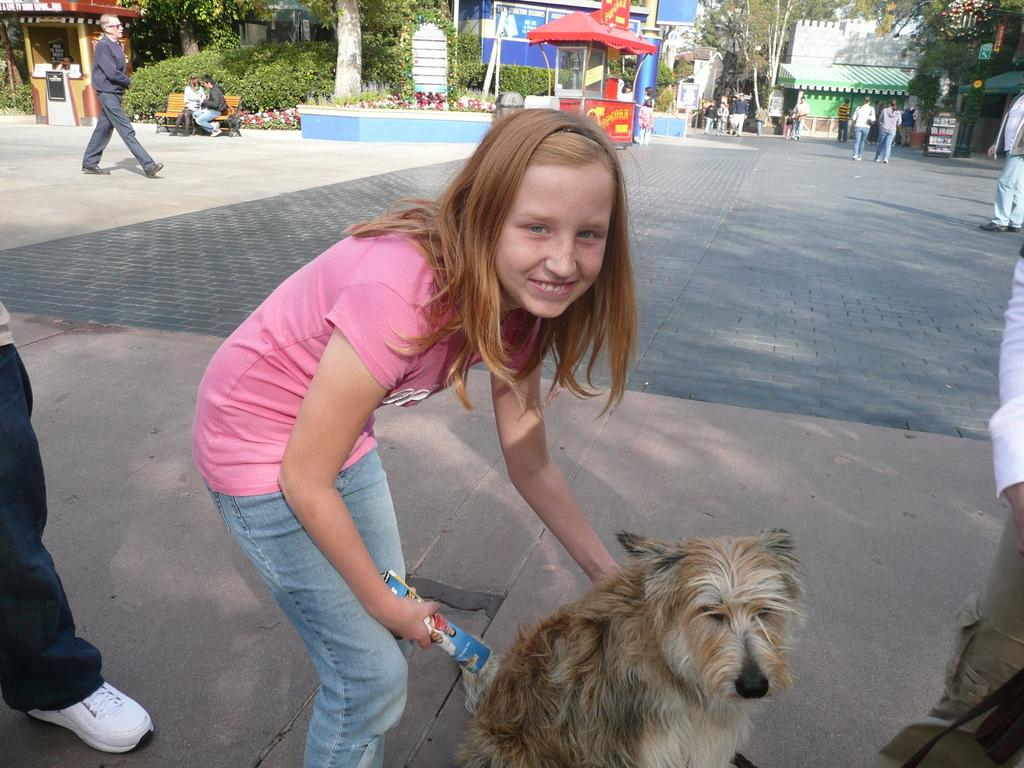What is the main subject of the image? There is a person in the image. What is the person wearing? The person is wearing a blue t-shirt. What is the person doing in the image? The person is bending towards a dog. What can be seen in the background of the image? There are people walking, a road, trees, and stalls in the background. How does the person sort the items on the stalls in the image? There is no indication in the image that the person is sorting items on the stalls. The person is bending towards a dog, and there is no mention of sorting or items on the stalls. 